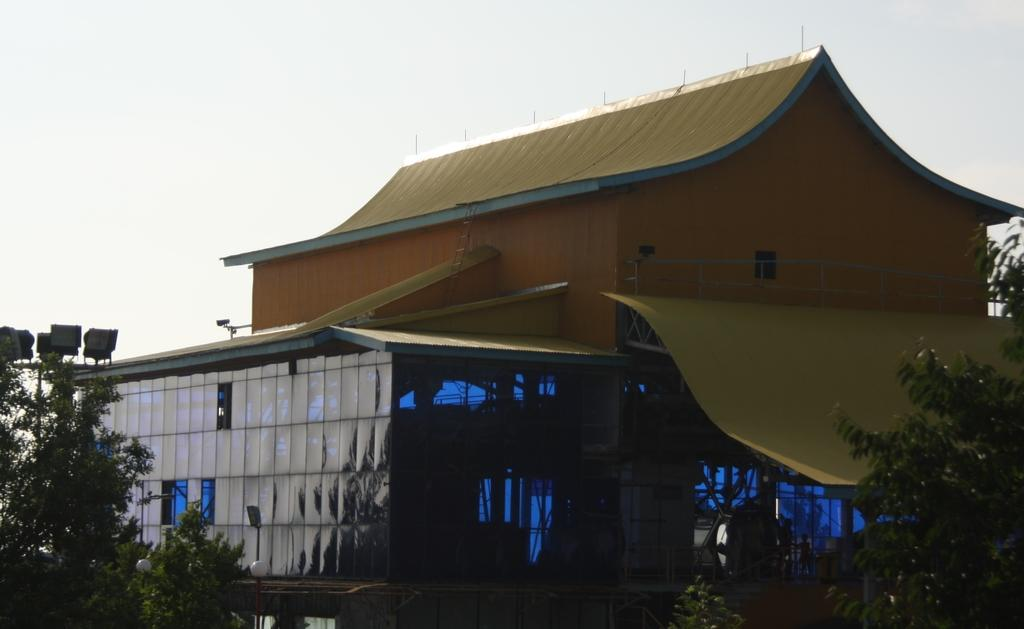What type of natural elements can be seen in the image? There are trees in the image. What else can be seen besides the trees? There is water visible in the image. Are there any man-made structures present? Yes, there are buildings in the image. What colors are the buildings? The buildings are yellow, orange, and black in color. What is visible in the background of the image? The sky is visible in the background of the image. Can you describe the detail of the leg in the image? There is no leg present in the image; it features trees, water, buildings, and the sky. 